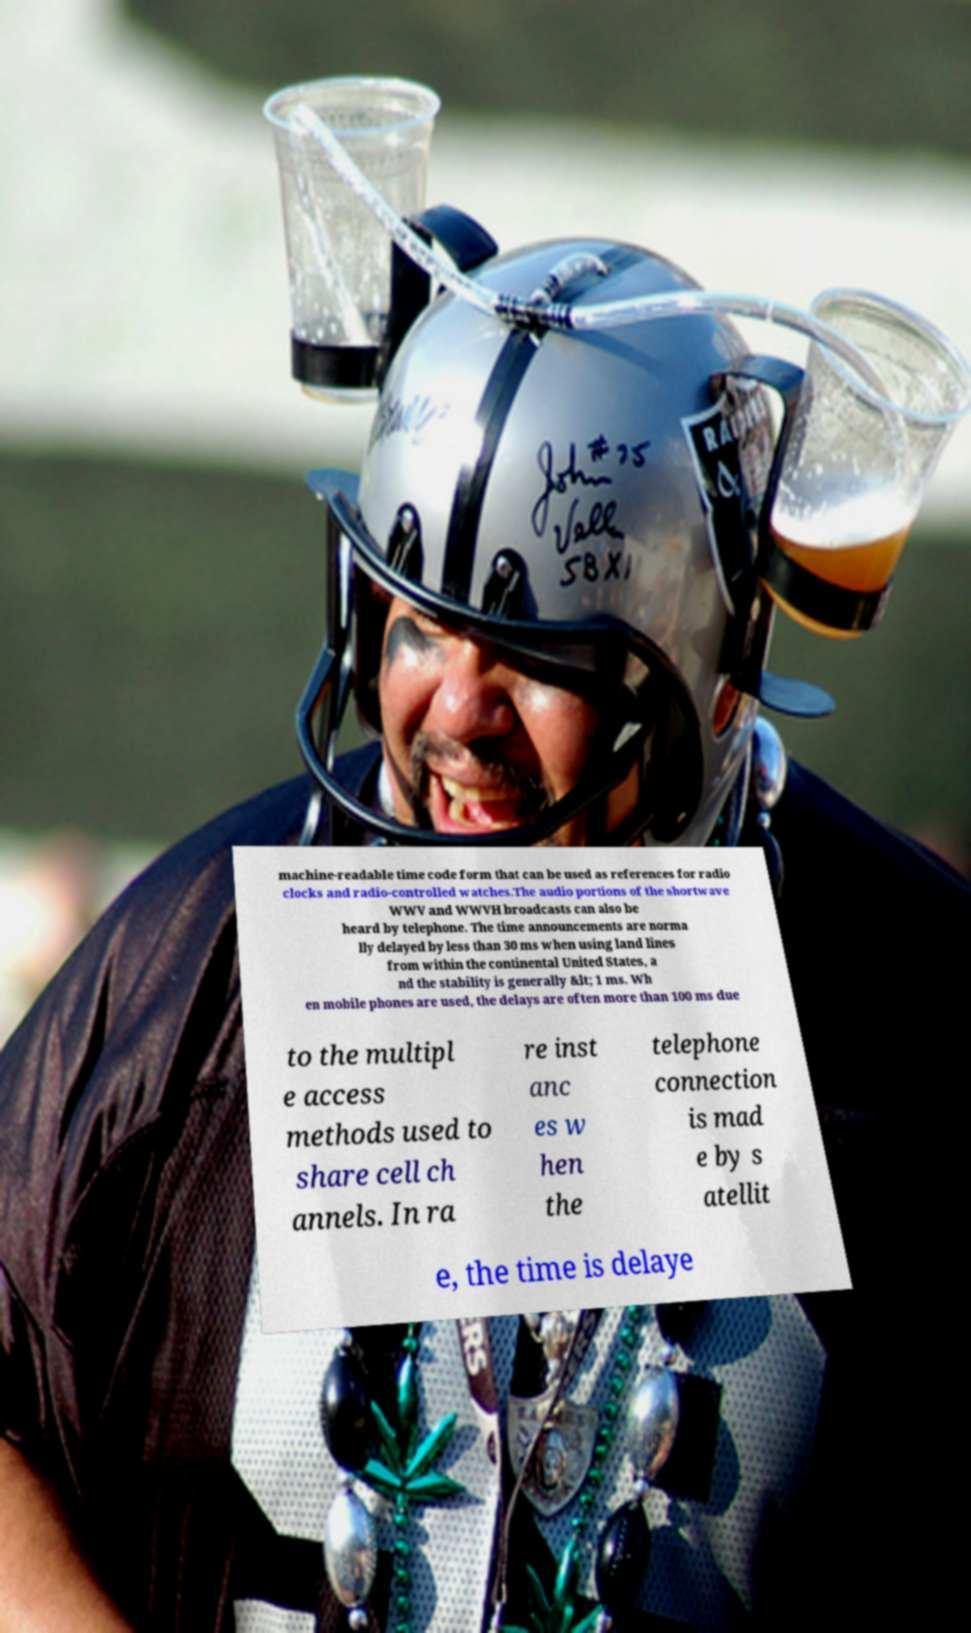Please read and relay the text visible in this image. What does it say? machine-readable time code form that can be used as references for radio clocks and radio-controlled watches.The audio portions of the shortwave WWV and WWVH broadcasts can also be heard by telephone. The time announcements are norma lly delayed by less than 30 ms when using land lines from within the continental United States, a nd the stability is generally &lt; 1 ms. Wh en mobile phones are used, the delays are often more than 100 ms due to the multipl e access methods used to share cell ch annels. In ra re inst anc es w hen the telephone connection is mad e by s atellit e, the time is delaye 